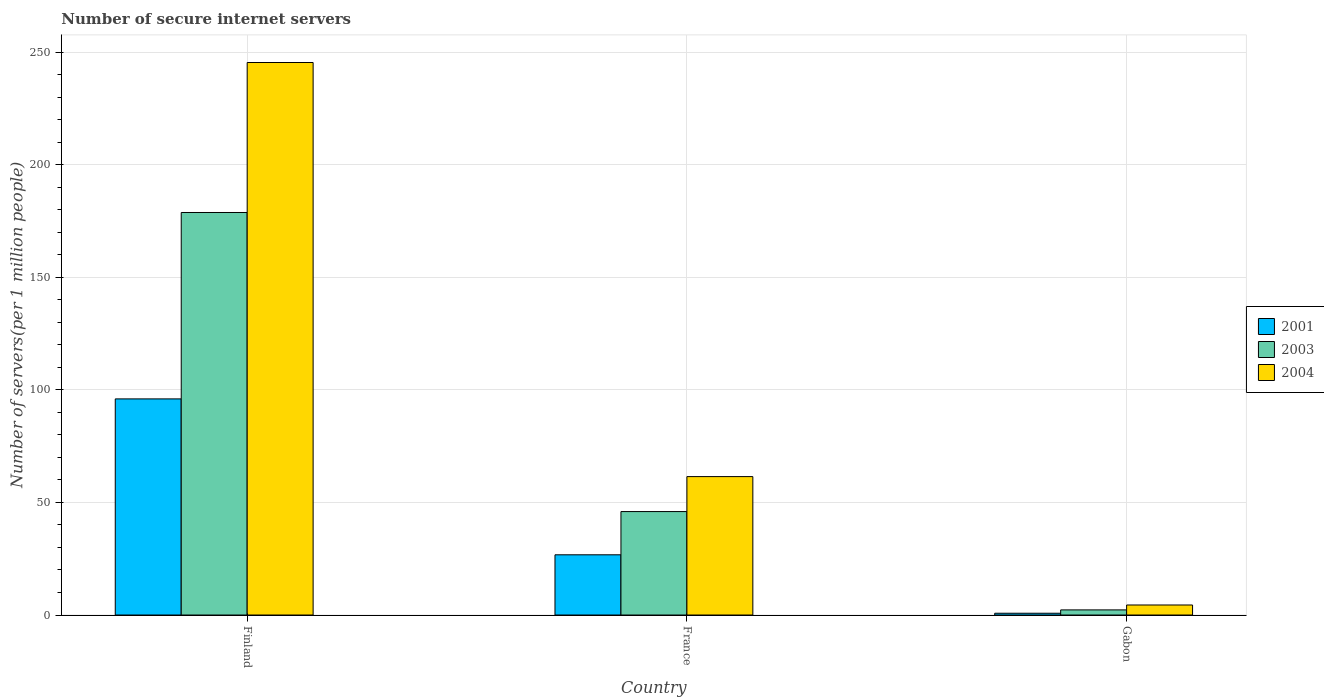How many different coloured bars are there?
Your response must be concise. 3. What is the label of the 3rd group of bars from the left?
Make the answer very short. Gabon. In how many cases, is the number of bars for a given country not equal to the number of legend labels?
Offer a very short reply. 0. What is the number of secure internet servers in 2003 in France?
Provide a succinct answer. 45.95. Across all countries, what is the maximum number of secure internet servers in 2004?
Your answer should be very brief. 245.4. Across all countries, what is the minimum number of secure internet servers in 2004?
Give a very brief answer. 4.45. In which country was the number of secure internet servers in 2004 maximum?
Keep it short and to the point. Finland. In which country was the number of secure internet servers in 2004 minimum?
Your answer should be compact. Gabon. What is the total number of secure internet servers in 2004 in the graph?
Provide a succinct answer. 311.33. What is the difference between the number of secure internet servers in 2004 in Finland and that in Gabon?
Provide a short and direct response. 240.95. What is the difference between the number of secure internet servers in 2003 in France and the number of secure internet servers in 2001 in Finland?
Your answer should be compact. -50.04. What is the average number of secure internet servers in 2003 per country?
Your response must be concise. 75.67. What is the difference between the number of secure internet servers of/in 2004 and number of secure internet servers of/in 2001 in Gabon?
Your response must be concise. 3.66. In how many countries, is the number of secure internet servers in 2003 greater than 120?
Your response must be concise. 1. What is the ratio of the number of secure internet servers in 2001 in Finland to that in Gabon?
Your response must be concise. 120.99. Is the number of secure internet servers in 2004 in France less than that in Gabon?
Offer a terse response. No. What is the difference between the highest and the second highest number of secure internet servers in 2003?
Provide a succinct answer. 176.51. What is the difference between the highest and the lowest number of secure internet servers in 2001?
Ensure brevity in your answer.  95.2. What does the 3rd bar from the left in France represents?
Keep it short and to the point. 2004. Is it the case that in every country, the sum of the number of secure internet servers in 2003 and number of secure internet servers in 2004 is greater than the number of secure internet servers in 2001?
Offer a very short reply. Yes. How many bars are there?
Offer a terse response. 9. Are the values on the major ticks of Y-axis written in scientific E-notation?
Make the answer very short. No. Does the graph contain grids?
Your answer should be very brief. Yes. Where does the legend appear in the graph?
Keep it short and to the point. Center right. What is the title of the graph?
Provide a succinct answer. Number of secure internet servers. Does "2010" appear as one of the legend labels in the graph?
Your response must be concise. No. What is the label or title of the X-axis?
Provide a succinct answer. Country. What is the label or title of the Y-axis?
Provide a succinct answer. Number of servers(per 1 million people). What is the Number of servers(per 1 million people) in 2001 in Finland?
Make the answer very short. 95.99. What is the Number of servers(per 1 million people) in 2003 in Finland?
Keep it short and to the point. 178.78. What is the Number of servers(per 1 million people) of 2004 in Finland?
Make the answer very short. 245.4. What is the Number of servers(per 1 million people) of 2001 in France?
Give a very brief answer. 26.74. What is the Number of servers(per 1 million people) of 2003 in France?
Offer a very short reply. 45.95. What is the Number of servers(per 1 million people) in 2004 in France?
Ensure brevity in your answer.  61.48. What is the Number of servers(per 1 million people) of 2001 in Gabon?
Your answer should be very brief. 0.79. What is the Number of servers(per 1 million people) of 2003 in Gabon?
Make the answer very short. 2.28. What is the Number of servers(per 1 million people) of 2004 in Gabon?
Keep it short and to the point. 4.45. Across all countries, what is the maximum Number of servers(per 1 million people) of 2001?
Your response must be concise. 95.99. Across all countries, what is the maximum Number of servers(per 1 million people) of 2003?
Make the answer very short. 178.78. Across all countries, what is the maximum Number of servers(per 1 million people) of 2004?
Your answer should be compact. 245.4. Across all countries, what is the minimum Number of servers(per 1 million people) of 2001?
Make the answer very short. 0.79. Across all countries, what is the minimum Number of servers(per 1 million people) in 2003?
Offer a very short reply. 2.28. Across all countries, what is the minimum Number of servers(per 1 million people) of 2004?
Keep it short and to the point. 4.45. What is the total Number of servers(per 1 million people) of 2001 in the graph?
Keep it short and to the point. 123.53. What is the total Number of servers(per 1 million people) in 2003 in the graph?
Make the answer very short. 227.01. What is the total Number of servers(per 1 million people) of 2004 in the graph?
Give a very brief answer. 311.33. What is the difference between the Number of servers(per 1 million people) of 2001 in Finland and that in France?
Your answer should be very brief. 69.25. What is the difference between the Number of servers(per 1 million people) in 2003 in Finland and that in France?
Provide a succinct answer. 132.84. What is the difference between the Number of servers(per 1 million people) of 2004 in Finland and that in France?
Make the answer very short. 183.92. What is the difference between the Number of servers(per 1 million people) in 2001 in Finland and that in Gabon?
Provide a short and direct response. 95.2. What is the difference between the Number of servers(per 1 million people) of 2003 in Finland and that in Gabon?
Keep it short and to the point. 176.51. What is the difference between the Number of servers(per 1 million people) of 2004 in Finland and that in Gabon?
Ensure brevity in your answer.  240.95. What is the difference between the Number of servers(per 1 million people) of 2001 in France and that in Gabon?
Ensure brevity in your answer.  25.95. What is the difference between the Number of servers(per 1 million people) of 2003 in France and that in Gabon?
Your answer should be very brief. 43.67. What is the difference between the Number of servers(per 1 million people) of 2004 in France and that in Gabon?
Offer a terse response. 57.03. What is the difference between the Number of servers(per 1 million people) of 2001 in Finland and the Number of servers(per 1 million people) of 2003 in France?
Your answer should be very brief. 50.04. What is the difference between the Number of servers(per 1 million people) of 2001 in Finland and the Number of servers(per 1 million people) of 2004 in France?
Keep it short and to the point. 34.51. What is the difference between the Number of servers(per 1 million people) in 2003 in Finland and the Number of servers(per 1 million people) in 2004 in France?
Make the answer very short. 117.3. What is the difference between the Number of servers(per 1 million people) in 2001 in Finland and the Number of servers(per 1 million people) in 2003 in Gabon?
Ensure brevity in your answer.  93.71. What is the difference between the Number of servers(per 1 million people) in 2001 in Finland and the Number of servers(per 1 million people) in 2004 in Gabon?
Keep it short and to the point. 91.54. What is the difference between the Number of servers(per 1 million people) in 2003 in Finland and the Number of servers(per 1 million people) in 2004 in Gabon?
Keep it short and to the point. 174.33. What is the difference between the Number of servers(per 1 million people) of 2001 in France and the Number of servers(per 1 million people) of 2003 in Gabon?
Keep it short and to the point. 24.47. What is the difference between the Number of servers(per 1 million people) in 2001 in France and the Number of servers(per 1 million people) in 2004 in Gabon?
Your response must be concise. 22.29. What is the difference between the Number of servers(per 1 million people) of 2003 in France and the Number of servers(per 1 million people) of 2004 in Gabon?
Provide a short and direct response. 41.49. What is the average Number of servers(per 1 million people) of 2001 per country?
Ensure brevity in your answer.  41.18. What is the average Number of servers(per 1 million people) of 2003 per country?
Your answer should be compact. 75.67. What is the average Number of servers(per 1 million people) in 2004 per country?
Provide a short and direct response. 103.78. What is the difference between the Number of servers(per 1 million people) of 2001 and Number of servers(per 1 million people) of 2003 in Finland?
Make the answer very short. -82.79. What is the difference between the Number of servers(per 1 million people) of 2001 and Number of servers(per 1 million people) of 2004 in Finland?
Provide a succinct answer. -149.41. What is the difference between the Number of servers(per 1 million people) in 2003 and Number of servers(per 1 million people) in 2004 in Finland?
Make the answer very short. -66.62. What is the difference between the Number of servers(per 1 million people) in 2001 and Number of servers(per 1 million people) in 2003 in France?
Ensure brevity in your answer.  -19.2. What is the difference between the Number of servers(per 1 million people) of 2001 and Number of servers(per 1 million people) of 2004 in France?
Offer a terse response. -34.73. What is the difference between the Number of servers(per 1 million people) in 2003 and Number of servers(per 1 million people) in 2004 in France?
Make the answer very short. -15.53. What is the difference between the Number of servers(per 1 million people) in 2001 and Number of servers(per 1 million people) in 2003 in Gabon?
Provide a short and direct response. -1.48. What is the difference between the Number of servers(per 1 million people) in 2001 and Number of servers(per 1 million people) in 2004 in Gabon?
Your answer should be very brief. -3.66. What is the difference between the Number of servers(per 1 million people) in 2003 and Number of servers(per 1 million people) in 2004 in Gabon?
Your answer should be very brief. -2.18. What is the ratio of the Number of servers(per 1 million people) in 2001 in Finland to that in France?
Give a very brief answer. 3.59. What is the ratio of the Number of servers(per 1 million people) of 2003 in Finland to that in France?
Keep it short and to the point. 3.89. What is the ratio of the Number of servers(per 1 million people) of 2004 in Finland to that in France?
Give a very brief answer. 3.99. What is the ratio of the Number of servers(per 1 million people) of 2001 in Finland to that in Gabon?
Your response must be concise. 120.99. What is the ratio of the Number of servers(per 1 million people) in 2003 in Finland to that in Gabon?
Provide a succinct answer. 78.55. What is the ratio of the Number of servers(per 1 million people) in 2004 in Finland to that in Gabon?
Give a very brief answer. 55.11. What is the ratio of the Number of servers(per 1 million people) of 2001 in France to that in Gabon?
Offer a terse response. 33.71. What is the ratio of the Number of servers(per 1 million people) in 2003 in France to that in Gabon?
Your answer should be very brief. 20.19. What is the ratio of the Number of servers(per 1 million people) of 2004 in France to that in Gabon?
Your answer should be compact. 13.81. What is the difference between the highest and the second highest Number of servers(per 1 million people) of 2001?
Give a very brief answer. 69.25. What is the difference between the highest and the second highest Number of servers(per 1 million people) in 2003?
Make the answer very short. 132.84. What is the difference between the highest and the second highest Number of servers(per 1 million people) in 2004?
Your answer should be compact. 183.92. What is the difference between the highest and the lowest Number of servers(per 1 million people) of 2001?
Give a very brief answer. 95.2. What is the difference between the highest and the lowest Number of servers(per 1 million people) in 2003?
Ensure brevity in your answer.  176.51. What is the difference between the highest and the lowest Number of servers(per 1 million people) of 2004?
Keep it short and to the point. 240.95. 